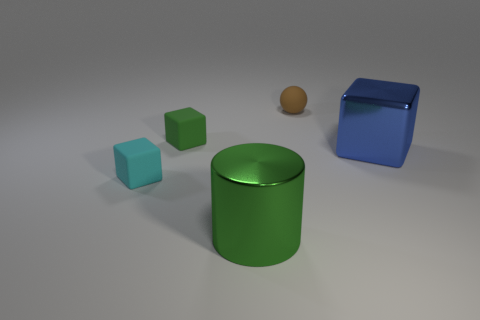There is a cyan thing that is the same shape as the small green object; what is it made of?
Give a very brief answer. Rubber. How many small brown rubber spheres are on the right side of the big metallic object on the left side of the tiny brown rubber object?
Your answer should be compact. 1. Is there anything else that has the same color as the big shiny cylinder?
Keep it short and to the point. Yes. What number of things are cyan rubber blocks or tiny matte blocks behind the blue shiny block?
Offer a very short reply. 2. What material is the object that is on the left side of the green rubber object behind the big object behind the big green shiny thing?
Give a very brief answer. Rubber. What size is the cylinder that is made of the same material as the blue thing?
Offer a terse response. Large. What color is the shiny thing that is on the left side of the rubber object behind the tiny green rubber block?
Ensure brevity in your answer.  Green. What number of other brown spheres have the same material as the brown sphere?
Your answer should be compact. 0. How many rubber objects are small cyan things or yellow things?
Your answer should be compact. 1. What is the material of the object that is the same size as the blue block?
Keep it short and to the point. Metal. 